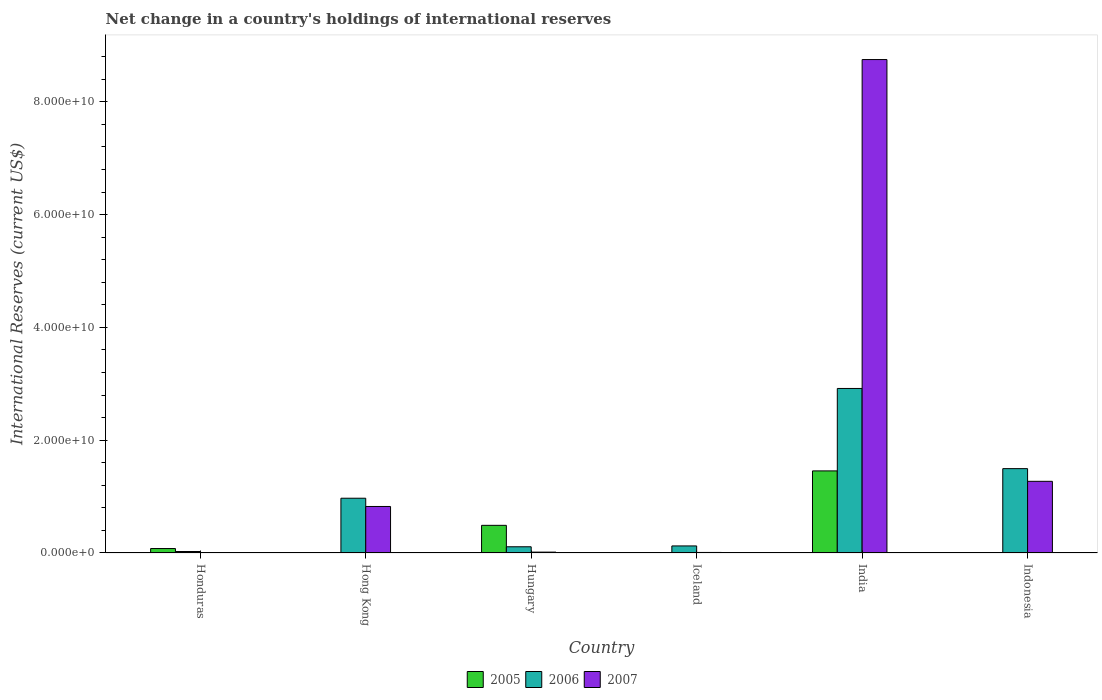How many different coloured bars are there?
Offer a very short reply. 3. Are the number of bars per tick equal to the number of legend labels?
Your answer should be compact. No. Are the number of bars on each tick of the X-axis equal?
Provide a short and direct response. No. How many bars are there on the 3rd tick from the left?
Provide a short and direct response. 3. What is the label of the 3rd group of bars from the left?
Offer a very short reply. Hungary. In how many cases, is the number of bars for a given country not equal to the number of legend labels?
Make the answer very short. 3. What is the international reserves in 2006 in Iceland?
Provide a succinct answer. 1.25e+09. Across all countries, what is the maximum international reserves in 2007?
Your answer should be compact. 8.75e+1. Across all countries, what is the minimum international reserves in 2005?
Your answer should be compact. 0. What is the total international reserves in 2007 in the graph?
Make the answer very short. 1.09e+11. What is the difference between the international reserves in 2007 in Hong Kong and that in Indonesia?
Make the answer very short. -4.46e+09. What is the difference between the international reserves in 2006 in India and the international reserves in 2007 in Honduras?
Your answer should be very brief. 2.92e+1. What is the average international reserves in 2005 per country?
Provide a succinct answer. 3.39e+09. What is the difference between the international reserves of/in 2007 and international reserves of/in 2006 in Iceland?
Ensure brevity in your answer.  -1.15e+09. What is the ratio of the international reserves in 2006 in Hong Kong to that in Hungary?
Provide a succinct answer. 8.81. Is the international reserves in 2006 in Hungary less than that in Iceland?
Give a very brief answer. Yes. What is the difference between the highest and the second highest international reserves in 2005?
Offer a very short reply. 4.12e+09. What is the difference between the highest and the lowest international reserves in 2006?
Your answer should be very brief. 2.89e+1. In how many countries, is the international reserves in 2006 greater than the average international reserves in 2006 taken over all countries?
Make the answer very short. 3. Is it the case that in every country, the sum of the international reserves in 2005 and international reserves in 2006 is greater than the international reserves in 2007?
Your response must be concise. No. How many countries are there in the graph?
Ensure brevity in your answer.  6. Does the graph contain grids?
Your answer should be very brief. No. How many legend labels are there?
Keep it short and to the point. 3. How are the legend labels stacked?
Your answer should be compact. Horizontal. What is the title of the graph?
Your answer should be compact. Net change in a country's holdings of international reserves. What is the label or title of the X-axis?
Provide a short and direct response. Country. What is the label or title of the Y-axis?
Make the answer very short. International Reserves (current US$). What is the International Reserves (current US$) in 2005 in Honduras?
Your response must be concise. 7.88e+08. What is the International Reserves (current US$) of 2006 in Honduras?
Offer a terse response. 2.63e+08. What is the International Reserves (current US$) in 2007 in Honduras?
Provide a short and direct response. 0. What is the International Reserves (current US$) in 2006 in Hong Kong?
Ensure brevity in your answer.  9.71e+09. What is the International Reserves (current US$) of 2007 in Hong Kong?
Offer a very short reply. 8.25e+09. What is the International Reserves (current US$) of 2005 in Hungary?
Offer a very short reply. 4.90e+09. What is the International Reserves (current US$) in 2006 in Hungary?
Provide a short and direct response. 1.10e+09. What is the International Reserves (current US$) of 2007 in Hungary?
Offer a terse response. 1.54e+08. What is the International Reserves (current US$) in 2005 in Iceland?
Your answer should be compact. 7.10e+07. What is the International Reserves (current US$) in 2006 in Iceland?
Keep it short and to the point. 1.25e+09. What is the International Reserves (current US$) of 2007 in Iceland?
Your response must be concise. 9.67e+07. What is the International Reserves (current US$) in 2005 in India?
Offer a terse response. 1.46e+1. What is the International Reserves (current US$) of 2006 in India?
Make the answer very short. 2.92e+1. What is the International Reserves (current US$) in 2007 in India?
Ensure brevity in your answer.  8.75e+1. What is the International Reserves (current US$) of 2005 in Indonesia?
Your response must be concise. 0. What is the International Reserves (current US$) of 2006 in Indonesia?
Your answer should be very brief. 1.50e+1. What is the International Reserves (current US$) in 2007 in Indonesia?
Offer a very short reply. 1.27e+1. Across all countries, what is the maximum International Reserves (current US$) of 2005?
Provide a short and direct response. 1.46e+1. Across all countries, what is the maximum International Reserves (current US$) of 2006?
Your answer should be very brief. 2.92e+1. Across all countries, what is the maximum International Reserves (current US$) in 2007?
Give a very brief answer. 8.75e+1. Across all countries, what is the minimum International Reserves (current US$) in 2006?
Your answer should be very brief. 2.63e+08. Across all countries, what is the minimum International Reserves (current US$) in 2007?
Make the answer very short. 0. What is the total International Reserves (current US$) of 2005 in the graph?
Your answer should be very brief. 2.03e+1. What is the total International Reserves (current US$) in 2006 in the graph?
Offer a terse response. 5.65e+1. What is the total International Reserves (current US$) of 2007 in the graph?
Make the answer very short. 1.09e+11. What is the difference between the International Reserves (current US$) in 2006 in Honduras and that in Hong Kong?
Your response must be concise. -9.45e+09. What is the difference between the International Reserves (current US$) in 2005 in Honduras and that in Hungary?
Provide a short and direct response. -4.12e+09. What is the difference between the International Reserves (current US$) of 2006 in Honduras and that in Hungary?
Offer a terse response. -8.39e+08. What is the difference between the International Reserves (current US$) of 2005 in Honduras and that in Iceland?
Provide a short and direct response. 7.17e+08. What is the difference between the International Reserves (current US$) in 2006 in Honduras and that in Iceland?
Your answer should be compact. -9.87e+08. What is the difference between the International Reserves (current US$) of 2005 in Honduras and that in India?
Provide a succinct answer. -1.38e+1. What is the difference between the International Reserves (current US$) of 2006 in Honduras and that in India?
Your response must be concise. -2.89e+1. What is the difference between the International Reserves (current US$) of 2006 in Honduras and that in Indonesia?
Give a very brief answer. -1.47e+1. What is the difference between the International Reserves (current US$) in 2006 in Hong Kong and that in Hungary?
Provide a succinct answer. 8.61e+09. What is the difference between the International Reserves (current US$) in 2007 in Hong Kong and that in Hungary?
Your answer should be very brief. 8.09e+09. What is the difference between the International Reserves (current US$) of 2006 in Hong Kong and that in Iceland?
Your response must be concise. 8.46e+09. What is the difference between the International Reserves (current US$) of 2007 in Hong Kong and that in Iceland?
Keep it short and to the point. 8.15e+09. What is the difference between the International Reserves (current US$) in 2006 in Hong Kong and that in India?
Provide a short and direct response. -1.95e+1. What is the difference between the International Reserves (current US$) of 2007 in Hong Kong and that in India?
Provide a succinct answer. -7.92e+1. What is the difference between the International Reserves (current US$) in 2006 in Hong Kong and that in Indonesia?
Offer a very short reply. -5.25e+09. What is the difference between the International Reserves (current US$) in 2007 in Hong Kong and that in Indonesia?
Keep it short and to the point. -4.46e+09. What is the difference between the International Reserves (current US$) in 2005 in Hungary and that in Iceland?
Provide a succinct answer. 4.83e+09. What is the difference between the International Reserves (current US$) of 2006 in Hungary and that in Iceland?
Your answer should be very brief. -1.48e+08. What is the difference between the International Reserves (current US$) of 2007 in Hungary and that in Iceland?
Make the answer very short. 5.71e+07. What is the difference between the International Reserves (current US$) of 2005 in Hungary and that in India?
Give a very brief answer. -9.65e+09. What is the difference between the International Reserves (current US$) in 2006 in Hungary and that in India?
Offer a terse response. -2.81e+1. What is the difference between the International Reserves (current US$) in 2007 in Hungary and that in India?
Offer a very short reply. -8.73e+1. What is the difference between the International Reserves (current US$) of 2006 in Hungary and that in Indonesia?
Offer a very short reply. -1.39e+1. What is the difference between the International Reserves (current US$) of 2007 in Hungary and that in Indonesia?
Your answer should be very brief. -1.26e+1. What is the difference between the International Reserves (current US$) in 2005 in Iceland and that in India?
Offer a terse response. -1.45e+1. What is the difference between the International Reserves (current US$) of 2006 in Iceland and that in India?
Offer a terse response. -2.79e+1. What is the difference between the International Reserves (current US$) in 2007 in Iceland and that in India?
Your response must be concise. -8.74e+1. What is the difference between the International Reserves (current US$) of 2006 in Iceland and that in Indonesia?
Ensure brevity in your answer.  -1.37e+1. What is the difference between the International Reserves (current US$) in 2007 in Iceland and that in Indonesia?
Provide a succinct answer. -1.26e+1. What is the difference between the International Reserves (current US$) of 2006 in India and that in Indonesia?
Offer a terse response. 1.42e+1. What is the difference between the International Reserves (current US$) in 2007 in India and that in Indonesia?
Your response must be concise. 7.48e+1. What is the difference between the International Reserves (current US$) of 2005 in Honduras and the International Reserves (current US$) of 2006 in Hong Kong?
Keep it short and to the point. -8.92e+09. What is the difference between the International Reserves (current US$) in 2005 in Honduras and the International Reserves (current US$) in 2007 in Hong Kong?
Your answer should be very brief. -7.46e+09. What is the difference between the International Reserves (current US$) of 2006 in Honduras and the International Reserves (current US$) of 2007 in Hong Kong?
Keep it short and to the point. -7.98e+09. What is the difference between the International Reserves (current US$) in 2005 in Honduras and the International Reserves (current US$) in 2006 in Hungary?
Offer a very short reply. -3.14e+08. What is the difference between the International Reserves (current US$) in 2005 in Honduras and the International Reserves (current US$) in 2007 in Hungary?
Offer a very short reply. 6.34e+08. What is the difference between the International Reserves (current US$) in 2006 in Honduras and the International Reserves (current US$) in 2007 in Hungary?
Give a very brief answer. 1.09e+08. What is the difference between the International Reserves (current US$) in 2005 in Honduras and the International Reserves (current US$) in 2006 in Iceland?
Your answer should be compact. -4.62e+08. What is the difference between the International Reserves (current US$) of 2005 in Honduras and the International Reserves (current US$) of 2007 in Iceland?
Your answer should be very brief. 6.91e+08. What is the difference between the International Reserves (current US$) in 2006 in Honduras and the International Reserves (current US$) in 2007 in Iceland?
Offer a very short reply. 1.66e+08. What is the difference between the International Reserves (current US$) of 2005 in Honduras and the International Reserves (current US$) of 2006 in India?
Keep it short and to the point. -2.84e+1. What is the difference between the International Reserves (current US$) in 2005 in Honduras and the International Reserves (current US$) in 2007 in India?
Ensure brevity in your answer.  -8.67e+1. What is the difference between the International Reserves (current US$) in 2006 in Honduras and the International Reserves (current US$) in 2007 in India?
Offer a very short reply. -8.72e+1. What is the difference between the International Reserves (current US$) in 2005 in Honduras and the International Reserves (current US$) in 2006 in Indonesia?
Your answer should be compact. -1.42e+1. What is the difference between the International Reserves (current US$) of 2005 in Honduras and the International Reserves (current US$) of 2007 in Indonesia?
Provide a short and direct response. -1.19e+1. What is the difference between the International Reserves (current US$) of 2006 in Honduras and the International Reserves (current US$) of 2007 in Indonesia?
Your answer should be very brief. -1.24e+1. What is the difference between the International Reserves (current US$) of 2006 in Hong Kong and the International Reserves (current US$) of 2007 in Hungary?
Keep it short and to the point. 9.55e+09. What is the difference between the International Reserves (current US$) in 2006 in Hong Kong and the International Reserves (current US$) in 2007 in Iceland?
Your response must be concise. 9.61e+09. What is the difference between the International Reserves (current US$) in 2006 in Hong Kong and the International Reserves (current US$) in 2007 in India?
Make the answer very short. -7.78e+1. What is the difference between the International Reserves (current US$) of 2006 in Hong Kong and the International Reserves (current US$) of 2007 in Indonesia?
Your response must be concise. -3.00e+09. What is the difference between the International Reserves (current US$) of 2005 in Hungary and the International Reserves (current US$) of 2006 in Iceland?
Keep it short and to the point. 3.65e+09. What is the difference between the International Reserves (current US$) of 2005 in Hungary and the International Reserves (current US$) of 2007 in Iceland?
Your answer should be compact. 4.81e+09. What is the difference between the International Reserves (current US$) in 2006 in Hungary and the International Reserves (current US$) in 2007 in Iceland?
Provide a succinct answer. 1.01e+09. What is the difference between the International Reserves (current US$) in 2005 in Hungary and the International Reserves (current US$) in 2006 in India?
Your answer should be very brief. -2.43e+1. What is the difference between the International Reserves (current US$) of 2005 in Hungary and the International Reserves (current US$) of 2007 in India?
Provide a short and direct response. -8.26e+1. What is the difference between the International Reserves (current US$) of 2006 in Hungary and the International Reserves (current US$) of 2007 in India?
Your response must be concise. -8.64e+1. What is the difference between the International Reserves (current US$) in 2005 in Hungary and the International Reserves (current US$) in 2006 in Indonesia?
Give a very brief answer. -1.01e+1. What is the difference between the International Reserves (current US$) in 2005 in Hungary and the International Reserves (current US$) in 2007 in Indonesia?
Your response must be concise. -7.80e+09. What is the difference between the International Reserves (current US$) of 2006 in Hungary and the International Reserves (current US$) of 2007 in Indonesia?
Your response must be concise. -1.16e+1. What is the difference between the International Reserves (current US$) in 2005 in Iceland and the International Reserves (current US$) in 2006 in India?
Your answer should be compact. -2.91e+1. What is the difference between the International Reserves (current US$) in 2005 in Iceland and the International Reserves (current US$) in 2007 in India?
Keep it short and to the point. -8.74e+1. What is the difference between the International Reserves (current US$) of 2006 in Iceland and the International Reserves (current US$) of 2007 in India?
Offer a very short reply. -8.62e+1. What is the difference between the International Reserves (current US$) in 2005 in Iceland and the International Reserves (current US$) in 2006 in Indonesia?
Give a very brief answer. -1.49e+1. What is the difference between the International Reserves (current US$) of 2005 in Iceland and the International Reserves (current US$) of 2007 in Indonesia?
Keep it short and to the point. -1.26e+1. What is the difference between the International Reserves (current US$) of 2006 in Iceland and the International Reserves (current US$) of 2007 in Indonesia?
Offer a terse response. -1.15e+1. What is the difference between the International Reserves (current US$) of 2005 in India and the International Reserves (current US$) of 2006 in Indonesia?
Provide a short and direct response. -4.04e+08. What is the difference between the International Reserves (current US$) in 2005 in India and the International Reserves (current US$) in 2007 in Indonesia?
Provide a succinct answer. 1.85e+09. What is the difference between the International Reserves (current US$) in 2006 in India and the International Reserves (current US$) in 2007 in Indonesia?
Provide a succinct answer. 1.65e+1. What is the average International Reserves (current US$) in 2005 per country?
Keep it short and to the point. 3.39e+09. What is the average International Reserves (current US$) of 2006 per country?
Provide a succinct answer. 9.41e+09. What is the average International Reserves (current US$) of 2007 per country?
Your answer should be compact. 1.81e+1. What is the difference between the International Reserves (current US$) in 2005 and International Reserves (current US$) in 2006 in Honduras?
Provide a short and direct response. 5.25e+08. What is the difference between the International Reserves (current US$) in 2006 and International Reserves (current US$) in 2007 in Hong Kong?
Keep it short and to the point. 1.46e+09. What is the difference between the International Reserves (current US$) in 2005 and International Reserves (current US$) in 2006 in Hungary?
Provide a succinct answer. 3.80e+09. What is the difference between the International Reserves (current US$) in 2005 and International Reserves (current US$) in 2007 in Hungary?
Provide a succinct answer. 4.75e+09. What is the difference between the International Reserves (current US$) in 2006 and International Reserves (current US$) in 2007 in Hungary?
Offer a terse response. 9.49e+08. What is the difference between the International Reserves (current US$) in 2005 and International Reserves (current US$) in 2006 in Iceland?
Ensure brevity in your answer.  -1.18e+09. What is the difference between the International Reserves (current US$) of 2005 and International Reserves (current US$) of 2007 in Iceland?
Ensure brevity in your answer.  -2.57e+07. What is the difference between the International Reserves (current US$) of 2006 and International Reserves (current US$) of 2007 in Iceland?
Offer a terse response. 1.15e+09. What is the difference between the International Reserves (current US$) in 2005 and International Reserves (current US$) in 2006 in India?
Provide a succinct answer. -1.46e+1. What is the difference between the International Reserves (current US$) of 2005 and International Reserves (current US$) of 2007 in India?
Your answer should be very brief. -7.29e+1. What is the difference between the International Reserves (current US$) in 2006 and International Reserves (current US$) in 2007 in India?
Ensure brevity in your answer.  -5.83e+1. What is the difference between the International Reserves (current US$) of 2006 and International Reserves (current US$) of 2007 in Indonesia?
Your answer should be very brief. 2.25e+09. What is the ratio of the International Reserves (current US$) in 2006 in Honduras to that in Hong Kong?
Your response must be concise. 0.03. What is the ratio of the International Reserves (current US$) in 2005 in Honduras to that in Hungary?
Offer a terse response. 0.16. What is the ratio of the International Reserves (current US$) of 2006 in Honduras to that in Hungary?
Your answer should be compact. 0.24. What is the ratio of the International Reserves (current US$) of 2005 in Honduras to that in Iceland?
Keep it short and to the point. 11.1. What is the ratio of the International Reserves (current US$) in 2006 in Honduras to that in Iceland?
Your response must be concise. 0.21. What is the ratio of the International Reserves (current US$) in 2005 in Honduras to that in India?
Ensure brevity in your answer.  0.05. What is the ratio of the International Reserves (current US$) in 2006 in Honduras to that in India?
Give a very brief answer. 0.01. What is the ratio of the International Reserves (current US$) of 2006 in Honduras to that in Indonesia?
Offer a very short reply. 0.02. What is the ratio of the International Reserves (current US$) of 2006 in Hong Kong to that in Hungary?
Provide a short and direct response. 8.81. What is the ratio of the International Reserves (current US$) in 2007 in Hong Kong to that in Hungary?
Your answer should be very brief. 53.61. What is the ratio of the International Reserves (current US$) in 2006 in Hong Kong to that in Iceland?
Keep it short and to the point. 7.77. What is the ratio of the International Reserves (current US$) in 2007 in Hong Kong to that in Iceland?
Provide a succinct answer. 85.27. What is the ratio of the International Reserves (current US$) of 2006 in Hong Kong to that in India?
Keep it short and to the point. 0.33. What is the ratio of the International Reserves (current US$) in 2007 in Hong Kong to that in India?
Offer a very short reply. 0.09. What is the ratio of the International Reserves (current US$) in 2006 in Hong Kong to that in Indonesia?
Give a very brief answer. 0.65. What is the ratio of the International Reserves (current US$) in 2007 in Hong Kong to that in Indonesia?
Your answer should be compact. 0.65. What is the ratio of the International Reserves (current US$) of 2005 in Hungary to that in Iceland?
Ensure brevity in your answer.  69.06. What is the ratio of the International Reserves (current US$) of 2006 in Hungary to that in Iceland?
Ensure brevity in your answer.  0.88. What is the ratio of the International Reserves (current US$) of 2007 in Hungary to that in Iceland?
Give a very brief answer. 1.59. What is the ratio of the International Reserves (current US$) in 2005 in Hungary to that in India?
Keep it short and to the point. 0.34. What is the ratio of the International Reserves (current US$) of 2006 in Hungary to that in India?
Your answer should be very brief. 0.04. What is the ratio of the International Reserves (current US$) in 2007 in Hungary to that in India?
Your answer should be very brief. 0. What is the ratio of the International Reserves (current US$) of 2006 in Hungary to that in Indonesia?
Ensure brevity in your answer.  0.07. What is the ratio of the International Reserves (current US$) of 2007 in Hungary to that in Indonesia?
Offer a very short reply. 0.01. What is the ratio of the International Reserves (current US$) in 2005 in Iceland to that in India?
Ensure brevity in your answer.  0. What is the ratio of the International Reserves (current US$) in 2006 in Iceland to that in India?
Give a very brief answer. 0.04. What is the ratio of the International Reserves (current US$) in 2007 in Iceland to that in India?
Provide a succinct answer. 0. What is the ratio of the International Reserves (current US$) of 2006 in Iceland to that in Indonesia?
Offer a very short reply. 0.08. What is the ratio of the International Reserves (current US$) of 2007 in Iceland to that in Indonesia?
Provide a succinct answer. 0.01. What is the ratio of the International Reserves (current US$) of 2006 in India to that in Indonesia?
Provide a short and direct response. 1.95. What is the ratio of the International Reserves (current US$) in 2007 in India to that in Indonesia?
Ensure brevity in your answer.  6.89. What is the difference between the highest and the second highest International Reserves (current US$) of 2005?
Keep it short and to the point. 9.65e+09. What is the difference between the highest and the second highest International Reserves (current US$) of 2006?
Your response must be concise. 1.42e+1. What is the difference between the highest and the second highest International Reserves (current US$) in 2007?
Your answer should be very brief. 7.48e+1. What is the difference between the highest and the lowest International Reserves (current US$) of 2005?
Your answer should be compact. 1.46e+1. What is the difference between the highest and the lowest International Reserves (current US$) in 2006?
Ensure brevity in your answer.  2.89e+1. What is the difference between the highest and the lowest International Reserves (current US$) of 2007?
Your response must be concise. 8.75e+1. 